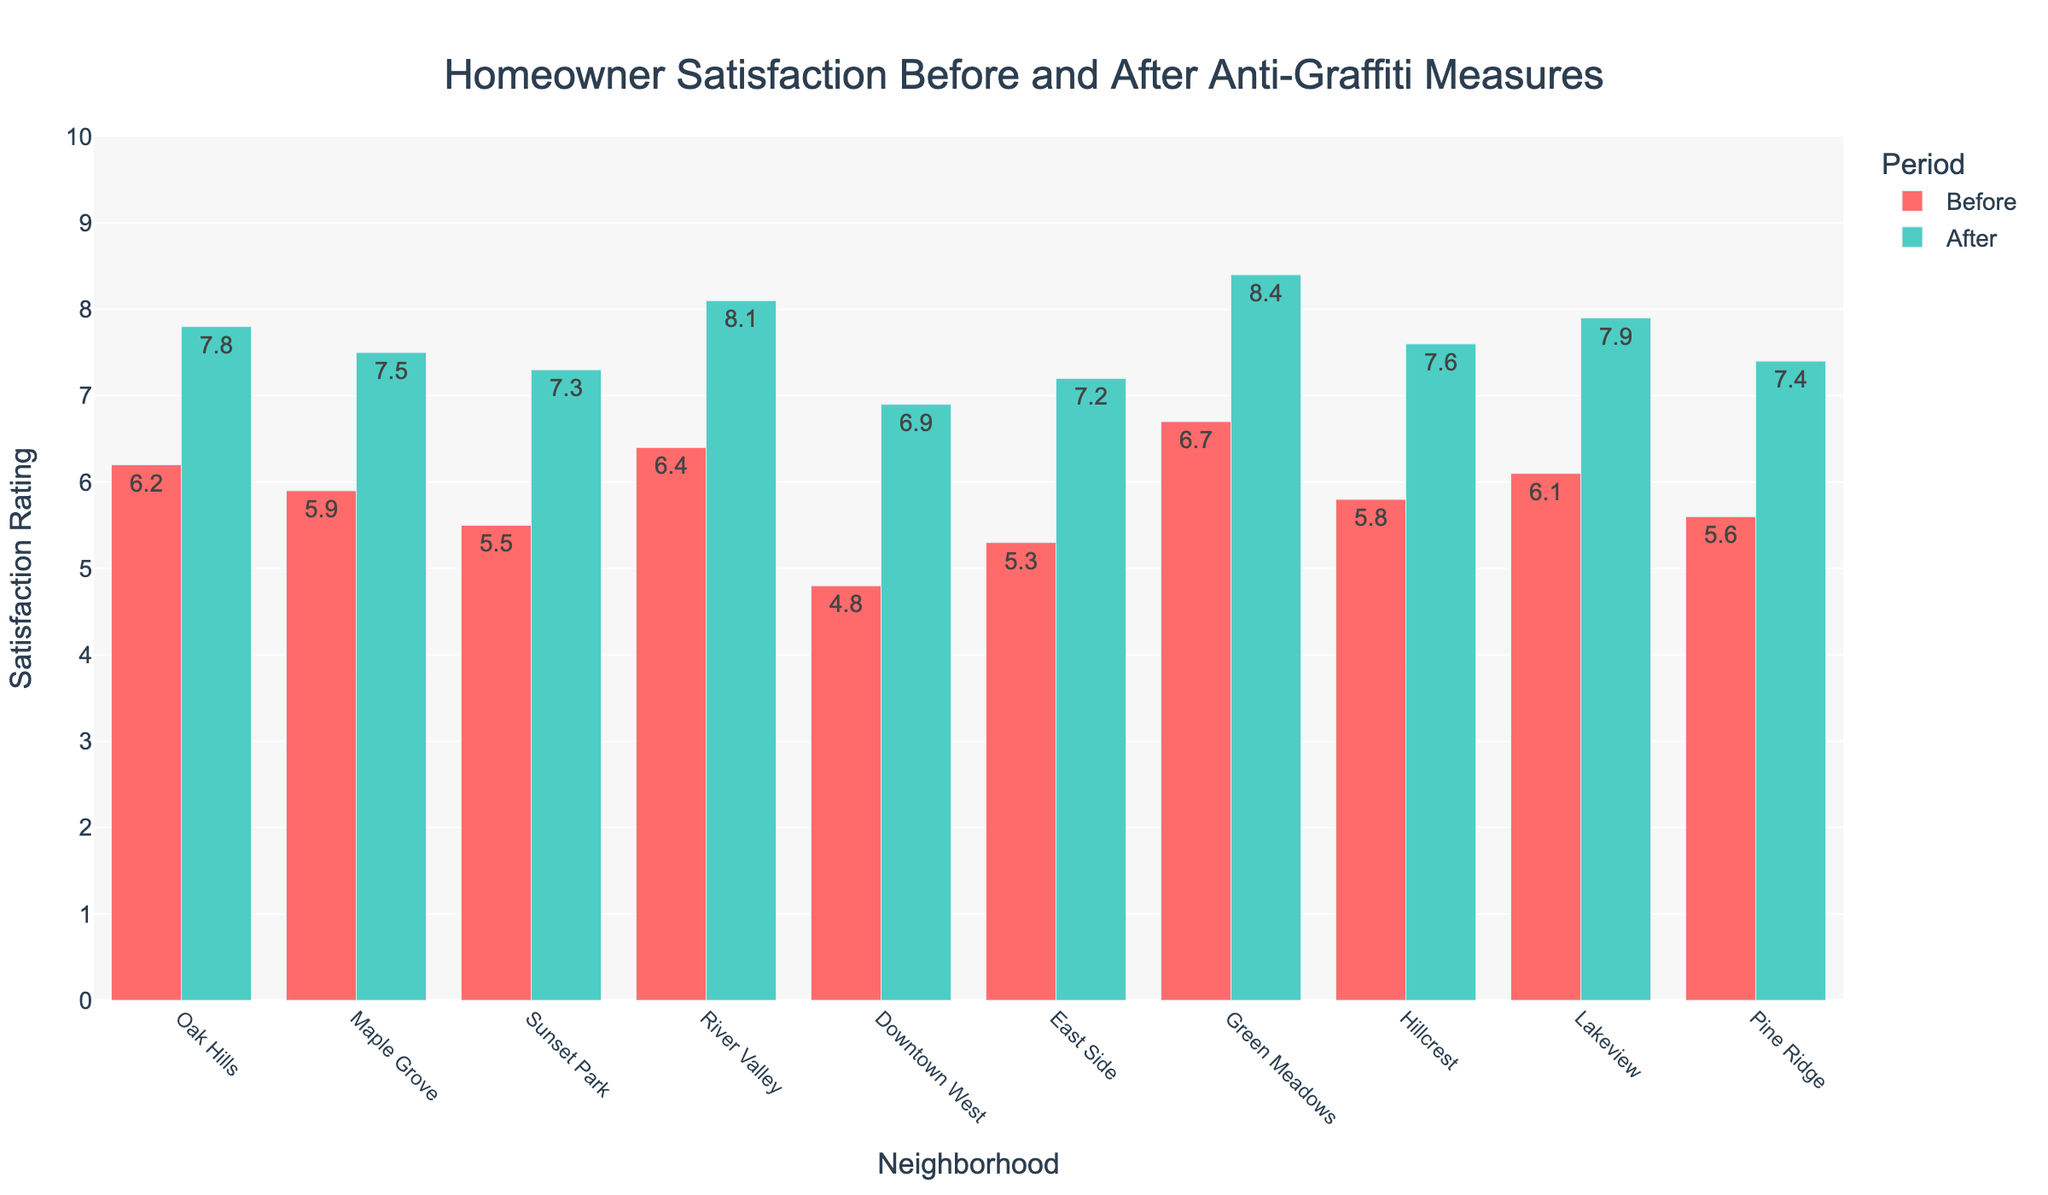What's the difference in homeowner satisfaction before and after anti-graffiti measures in River Valley? Subtract the satisfaction rating before the measures (6.4) from the rating after the measures (8.1). 8.1 - 6.4 = 1.7
Answer: 1.7 Which neighborhood had the highest increase in satisfaction after the implementation of anti-graffiti measures? Calculate the difference for each neighborhood, then identify the largest. Green Meadows has the largest increase: 8.4 - 6.7 = 1.7.
Answer: Green Meadows What is the average satisfaction rating after the anti-graffiti measures were implemented across all neighborhoods? Sum the after ratings and divide by the number of neighborhoods: (7.8 + 7.5 + 7.3 + 8.1 + 6.9 + 7.2 + 8.4 + 7.6 + 7.9 + 7.4) / 10 = 7.61
Answer: 7.61 Which neighborhoods had a satisfaction rating greater than 8 after the anti-graffiti measures? Compare the after ratings to 8 and list those greater: River Valley (8.1) and Green Meadows (8.4).
Answer: River Valley, Green Meadows What is the total increase in satisfaction across all neighborhoods after the anti-graffiti measures? Sum the differences between after and before ratings for all neighborhoods: (7.8-6.2) + (7.5-5.9) + (7.3-5.5) + (8.1-6.4) + (6.9-4.8) + (7.2-5.3) + (8.4-6.7) + (7.6-5.8) + (7.9-6.1) + (7.4-5.6) = 17.8
Answer: 17.8 Is home satisfaction in Sunset Park better than in Downtown West after the anti-graffiti measures? Compare the after ratings: Sunset Park (7.3) vs. Downtown West (6.9). Sunset Park has a higher rating.
Answer: Yes What is the median homeowner satisfaction rating before the anti-graffiti measures? Order the before ratings: 4.8, 5.3, 5.5, 5.6, 5.8, 5.9, 6.1, 6.2, 6.4, 6.7. The median is the average of the 5th and 6th values: (5.8 + 5.9) / 2 = 5.85
Answer: 5.85 In which neighborhood did the satisfaction rating increase the least after the anti-graffiti measures? Calculate the differences and identify the smallest increase: Green Meadows has the largest increase at 1.7, so it isn't Green Meadows (others larger). Downtown West had the smallest increase: 6.9 - 4.8 = 2.1
Answer: Downtown West 